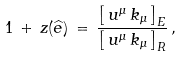Convert formula to latex. <formula><loc_0><loc_0><loc_500><loc_500>1 \, + \, z ( { \widehat { e } } ) \, = \, \frac { \left [ \, u ^ { \mu } \, k _ { \mu } \, \right ] _ { E } } { \left [ \, u ^ { \mu } \, k _ { \mu } \, \right ] _ { R } } \, ,</formula> 